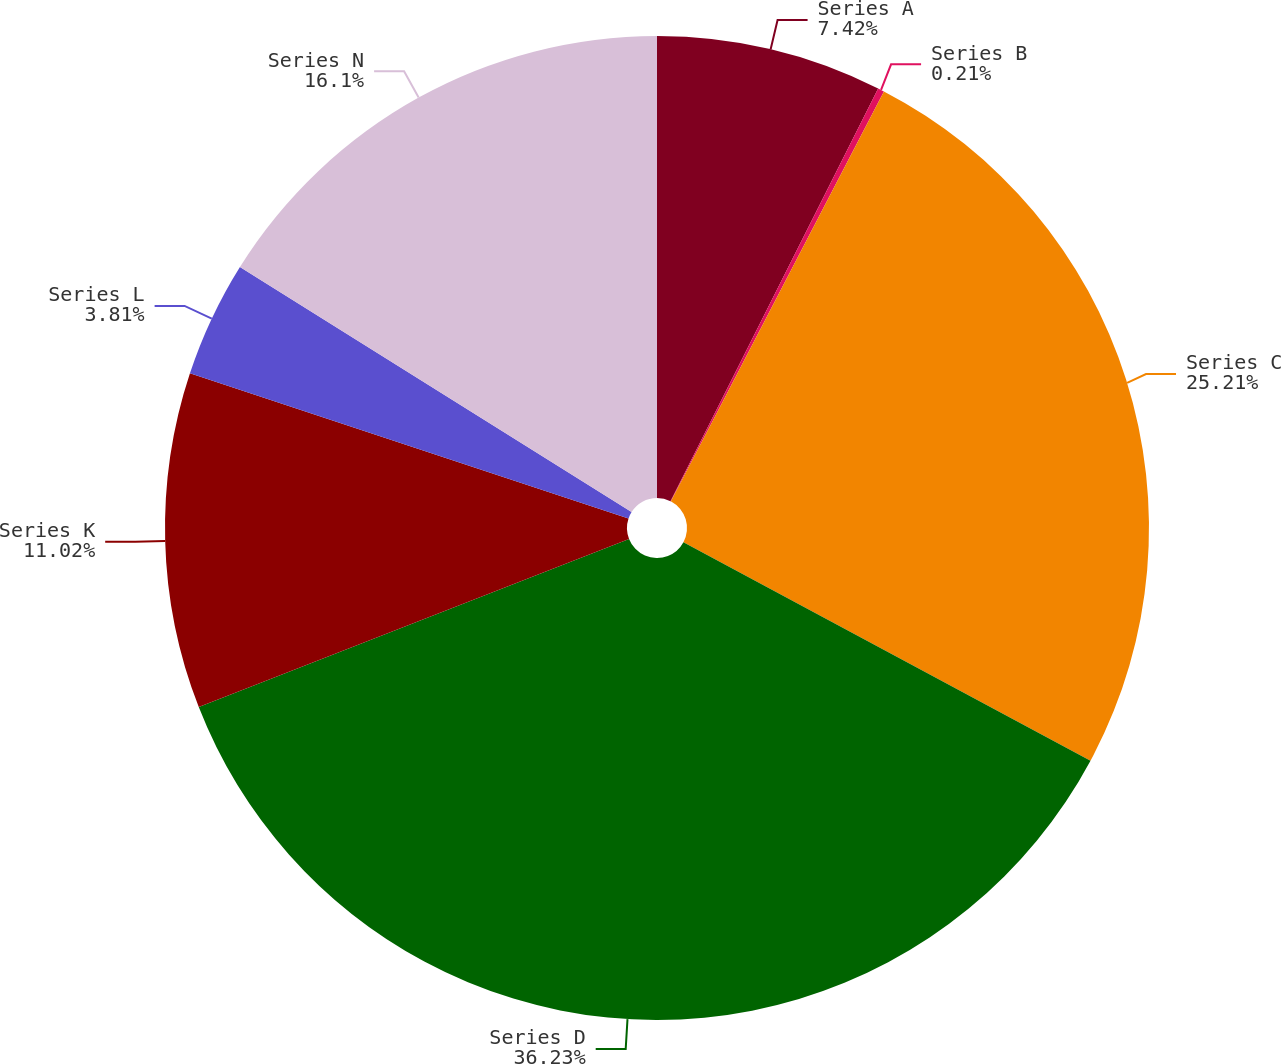<chart> <loc_0><loc_0><loc_500><loc_500><pie_chart><fcel>Series A<fcel>Series B<fcel>Series C<fcel>Series D<fcel>Series K<fcel>Series L<fcel>Series N<nl><fcel>7.42%<fcel>0.21%<fcel>25.21%<fcel>36.23%<fcel>11.02%<fcel>3.81%<fcel>16.1%<nl></chart> 